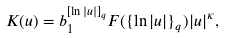<formula> <loc_0><loc_0><loc_500><loc_500>K ( u ) = b _ { 1 } ^ { [ \ln | u | ] _ { q } } F ( \{ \ln | u | \} _ { q } ) | u | ^ { \kappa } ,</formula> 